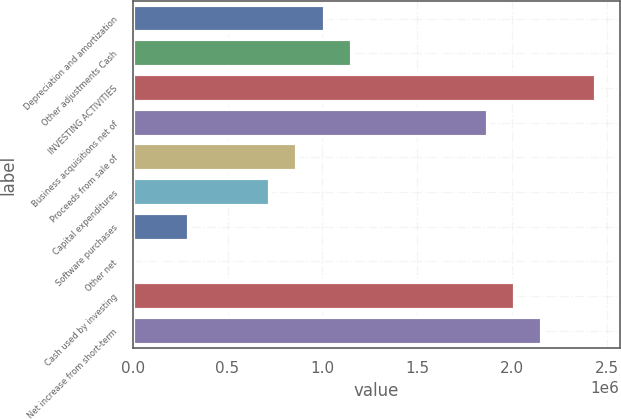Convert chart. <chart><loc_0><loc_0><loc_500><loc_500><bar_chart><fcel>Depreciation and amortization<fcel>Other adjustments Cash<fcel>INVESTING ACTIVITIES<fcel>Business acquisitions net of<fcel>Proceeds from sale of<fcel>Capital expenditures<fcel>Software purchases<fcel>Other net<fcel>Cash used by investing<fcel>Net increase from short-term<nl><fcel>1.01168e+06<fcel>1.15499e+06<fcel>2.44473e+06<fcel>1.87151e+06<fcel>868379<fcel>725074<fcel>295159<fcel>8549<fcel>2.01482e+06<fcel>2.15812e+06<nl></chart> 